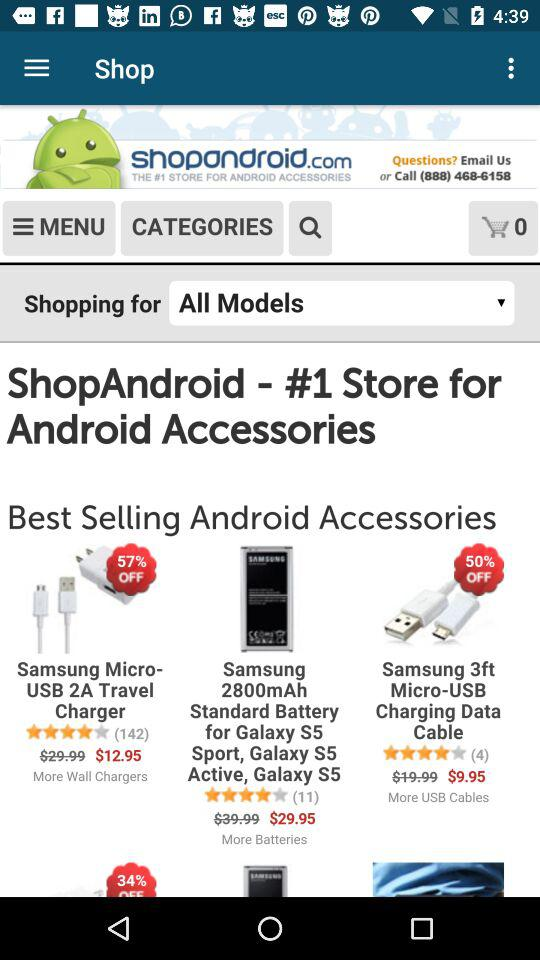Which are the different best selling android accessories? The different best selling android accessories are the "Samsung Micro-USB 2A Travel Charger", the "Samsung 2800mAh Standard Battery for Galaxy S5 Sport, Galaxy S5 Active, Galaxy S5" and the "Samsung 3ft Micro-USB Charging Data Cable". 